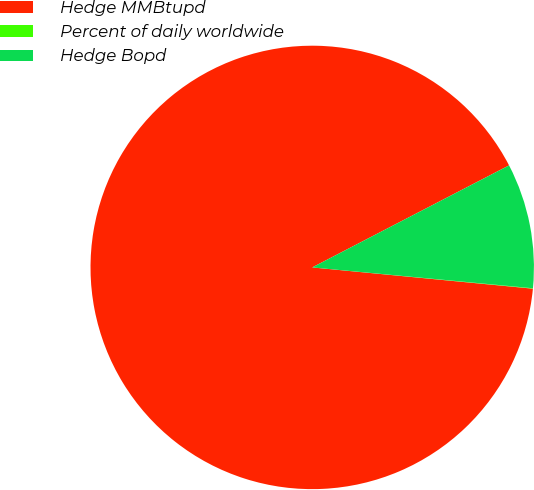Convert chart. <chart><loc_0><loc_0><loc_500><loc_500><pie_chart><fcel>Hedge MMBtupd<fcel>Percent of daily worldwide<fcel>Hedge Bopd<nl><fcel>90.86%<fcel>0.03%<fcel>9.11%<nl></chart> 